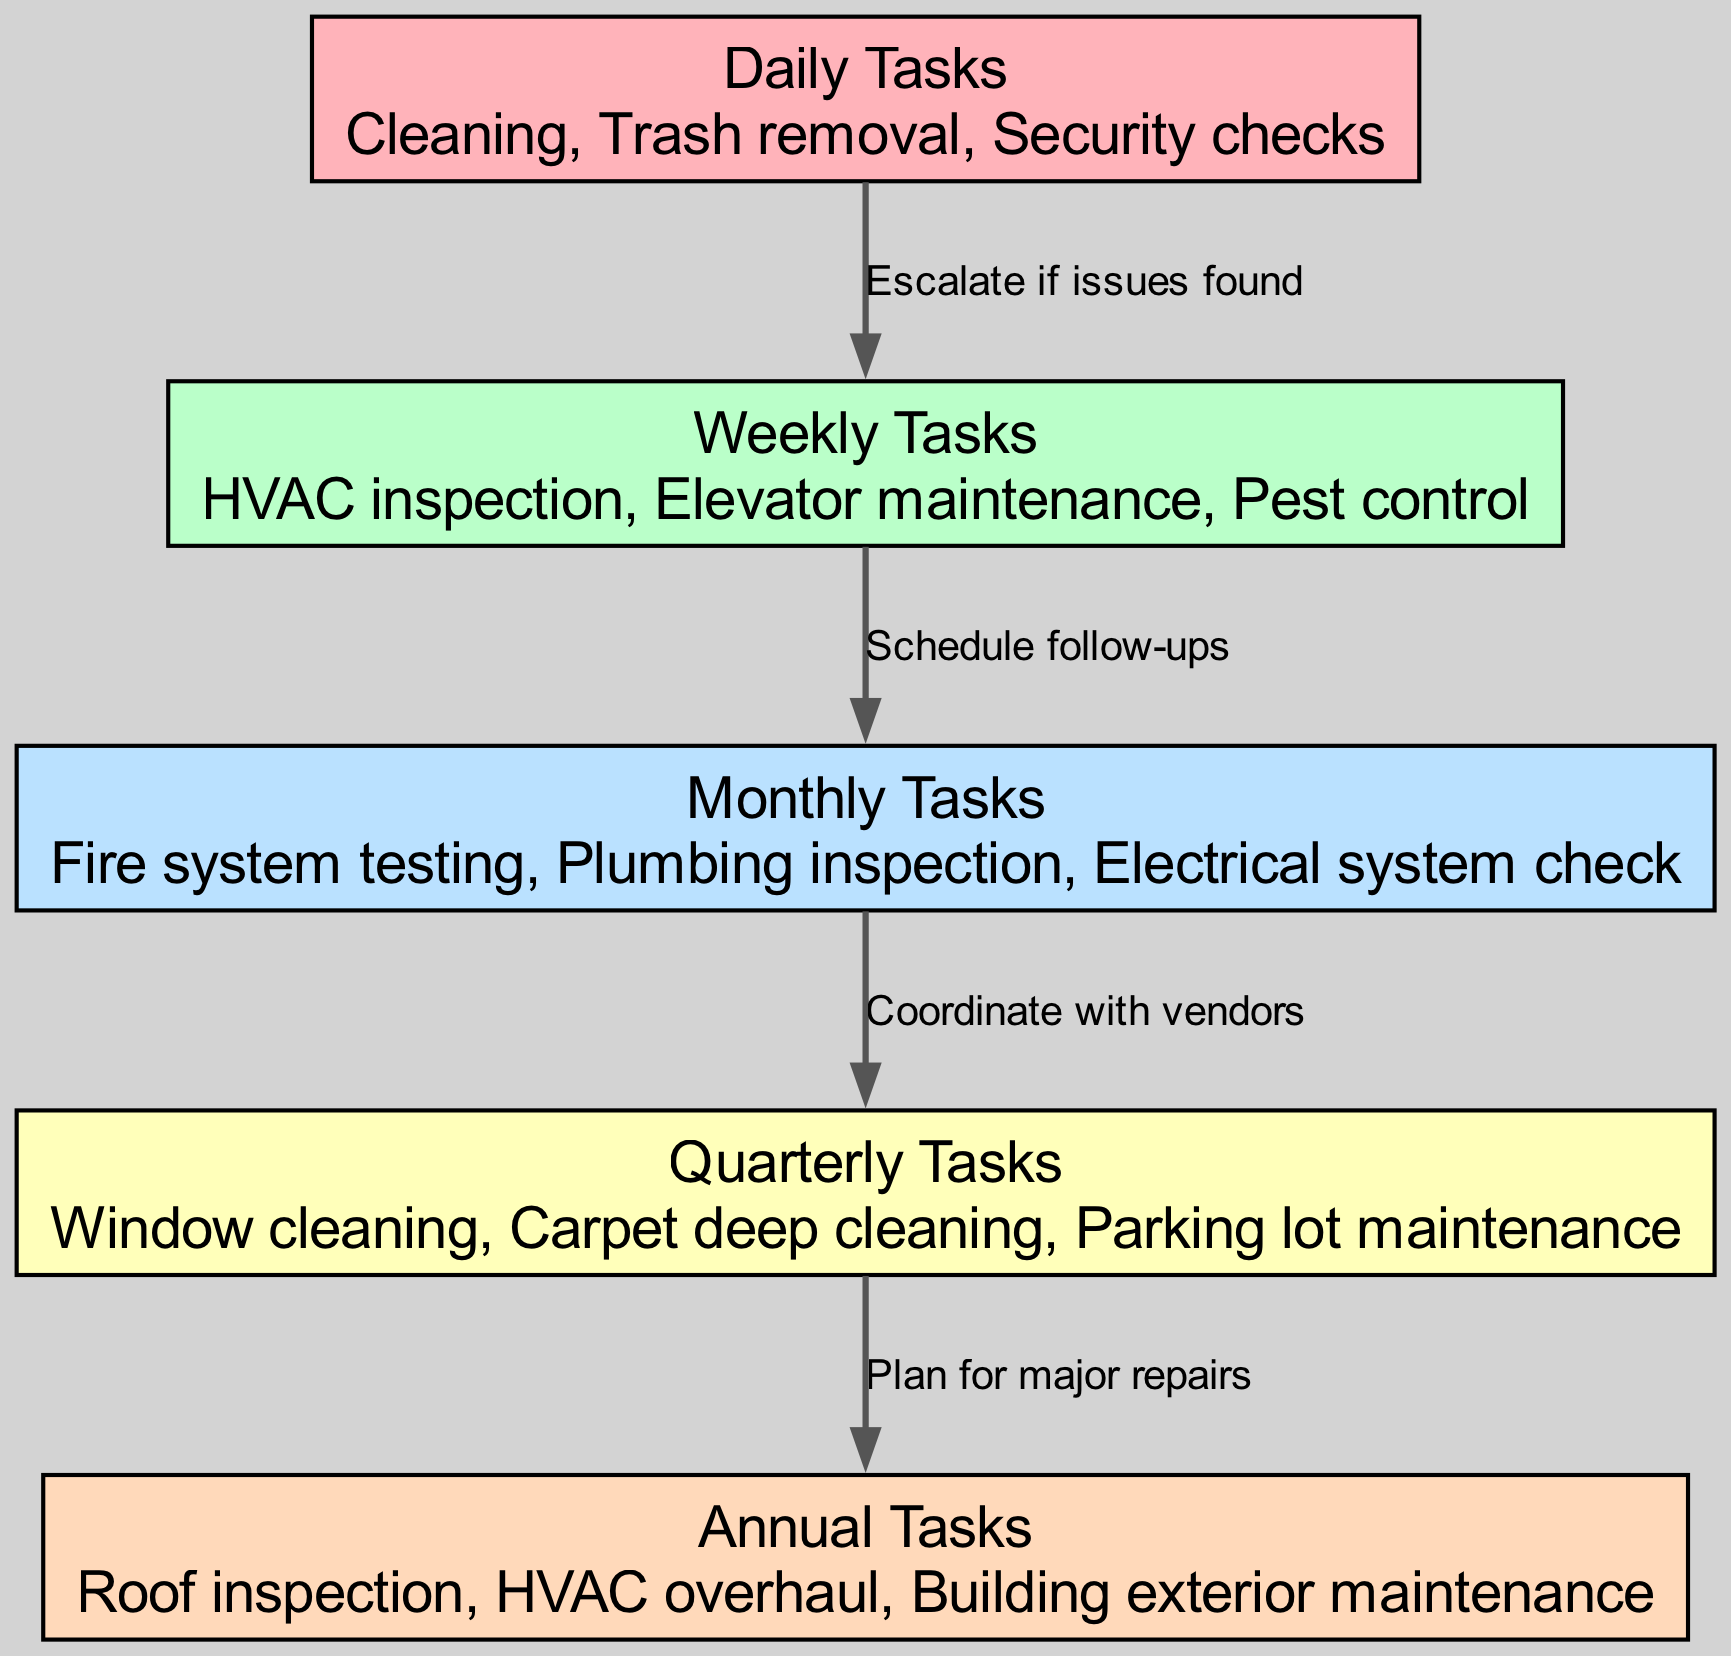What are the daily tasks listed in the diagram? The daily tasks listed in the diagram are "Cleaning, Trash removal, Security checks." This information is found directly in the node labeled "Daily Tasks" which contains a description of the daily maintenance activities.
Answer: Cleaning, Trash removal, Security checks How many quarterly tasks are there? The diagram shows only one node for "Quarterly Tasks," which lists three specific tasks. The count of distinct tasks is found in the details section of that node.
Answer: 3 What are the follow-ups scheduled after weekly tasks? The diagram indicates that the follow-up action after "Weekly Tasks" is to "Schedule follow-ups," which is explicitly stated as the label connecting the "Weekly Tasks" node to the "Monthly Tasks" node.
Answer: Schedule follow-ups Which task escalates issues found during daily monitoring? This is identified by examining the edge from "Daily Tasks" to "Weekly Tasks," where it states "Escalate if issues found," indicating that this action takes place after daily checks.
Answer: Escalate if issues found What tasks are coordinated after monthly inspections? The diagram states that after "Monthly Tasks," the next step is to "Coordinate with vendors," which connects the "Monthly Tasks" node to the "Quarterly Tasks" node, indicating vendor involvement is critical.
Answer: Coordinate with vendors What type of tasks could lead to major repairs in this facility? The edge leading from "Quarterly Tasks" to "Annual Tasks" includes the label "Plan for major repairs," suggesting that tasks from the "Quarterly Tasks" node can potentially uncover issues that lead to major repairs categorized under annual maintenance.
Answer: Plan for major repairs What color represents the monthly tasks in the diagram? Each task group in the diagram is color-coded, with "Monthly Tasks" specifically represented in light blue. This can be determined by examining the fill color in the node for "Monthly Tasks."
Answer: Light blue How many total maintenance schedule categories are depicted? By counting the nodes on the diagram, we see that there are five distinct categories: Daily, Weekly, Monthly, Quarterly, and Annual. Thus, we can quickly sum up the categories present.
Answer: 5 